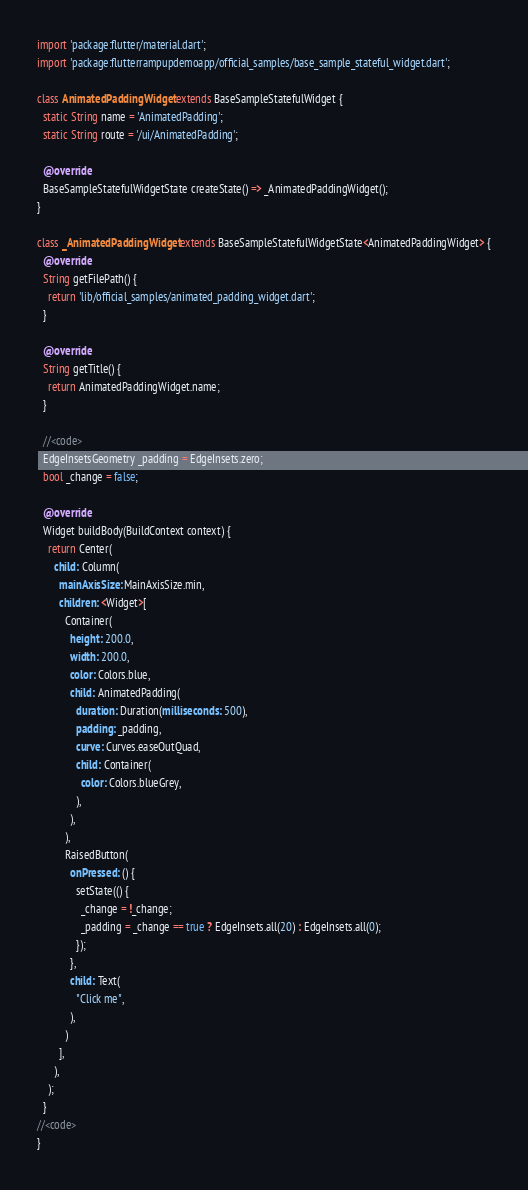Convert code to text. <code><loc_0><loc_0><loc_500><loc_500><_Dart_>import 'package:flutter/material.dart';
import 'package:flutterrampupdemoapp/official_samples/base_sample_stateful_widget.dart';

class AnimatedPaddingWidget extends BaseSampleStatefulWidget {
  static String name = 'AnimatedPadding';
  static String route = '/ui/AnimatedPadding';

  @override
  BaseSampleStatefulWidgetState createState() => _AnimatedPaddingWidget();
}

class _AnimatedPaddingWidget extends BaseSampleStatefulWidgetState<AnimatedPaddingWidget> {
  @override
  String getFilePath() {
    return 'lib/official_samples/animated_padding_widget.dart';
  }

  @override
  String getTitle() {
    return AnimatedPaddingWidget.name;
  }

  //<code>
  EdgeInsetsGeometry _padding = EdgeInsets.zero;
  bool _change = false;

  @override
  Widget buildBody(BuildContext context) {
    return Center(
      child: Column(
        mainAxisSize: MainAxisSize.min,
        children: <Widget>[
          Container(
            height: 200.0,
            width: 200.0,
            color: Colors.blue,
            child: AnimatedPadding(
              duration: Duration(milliseconds: 500),
              padding: _padding,
              curve: Curves.easeOutQuad,
              child: Container(
                color: Colors.blueGrey,
              ),
            ),
          ),
          RaisedButton(
            onPressed: () {
              setState(() {
                _change = !_change;
                _padding = _change == true ? EdgeInsets.all(20) : EdgeInsets.all(0);
              });
            },
            child: Text(
              "Click me",
            ),
          )
        ],
      ),
    );
  }
//<code>
}
</code> 